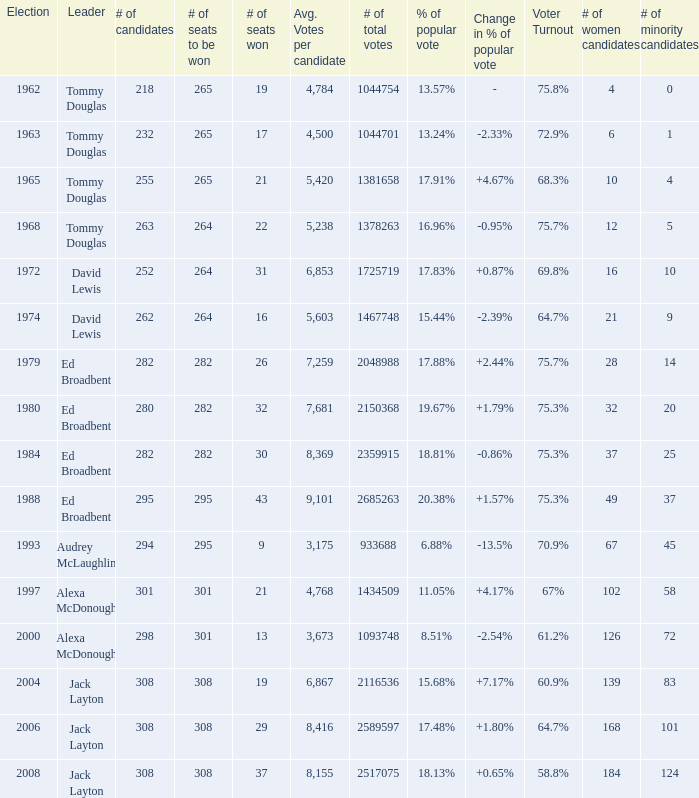Name the number of candidates for # of seats won being 43 295.0. 